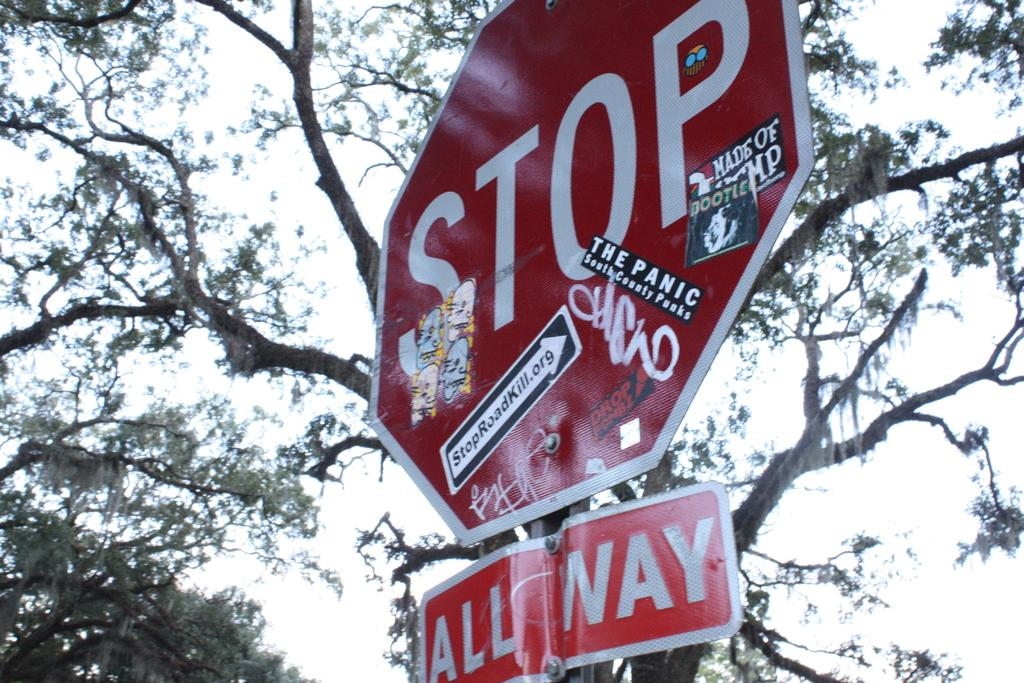<image>
Provide a brief description of the given image. Stop all Way stop sign with many pictures on it. 